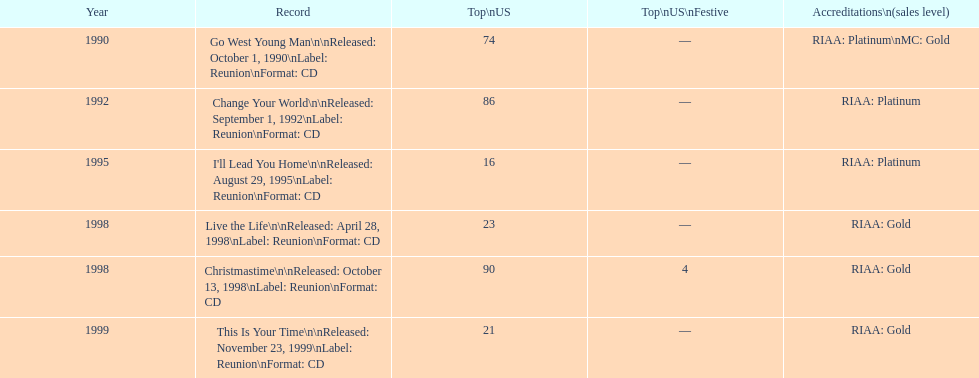Among michael w. smith's albums, which one had the top ranking on the us chart? I'll Lead You Home. 